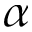<formula> <loc_0><loc_0><loc_500><loc_500>\alpha</formula> 